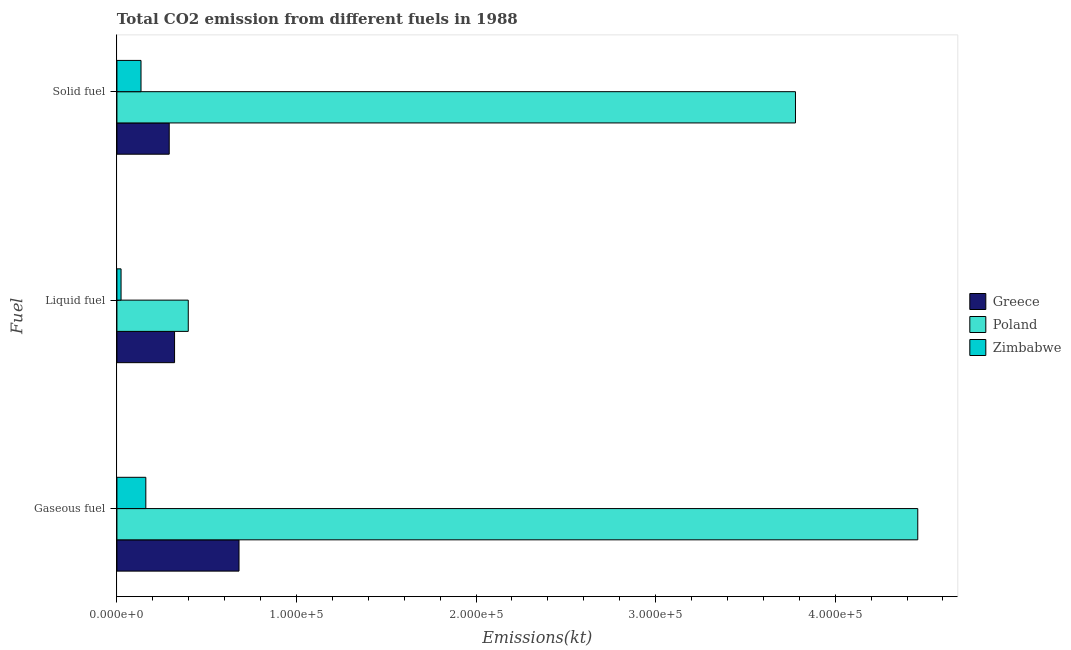How many different coloured bars are there?
Give a very brief answer. 3. How many groups of bars are there?
Provide a succinct answer. 3. Are the number of bars on each tick of the Y-axis equal?
Provide a succinct answer. Yes. How many bars are there on the 1st tick from the top?
Your answer should be very brief. 3. How many bars are there on the 1st tick from the bottom?
Make the answer very short. 3. What is the label of the 2nd group of bars from the top?
Make the answer very short. Liquid fuel. What is the amount of co2 emissions from gaseous fuel in Poland?
Provide a succinct answer. 4.46e+05. Across all countries, what is the maximum amount of co2 emissions from solid fuel?
Provide a succinct answer. 3.78e+05. Across all countries, what is the minimum amount of co2 emissions from solid fuel?
Provide a succinct answer. 1.34e+04. In which country was the amount of co2 emissions from liquid fuel minimum?
Provide a short and direct response. Zimbabwe. What is the total amount of co2 emissions from gaseous fuel in the graph?
Your answer should be very brief. 5.30e+05. What is the difference between the amount of co2 emissions from solid fuel in Poland and that in Greece?
Your answer should be compact. 3.49e+05. What is the difference between the amount of co2 emissions from solid fuel in Poland and the amount of co2 emissions from gaseous fuel in Zimbabwe?
Offer a terse response. 3.62e+05. What is the average amount of co2 emissions from solid fuel per country?
Offer a very short reply. 1.40e+05. What is the difference between the amount of co2 emissions from solid fuel and amount of co2 emissions from liquid fuel in Zimbabwe?
Offer a terse response. 1.11e+04. In how many countries, is the amount of co2 emissions from liquid fuel greater than 100000 kt?
Your response must be concise. 0. What is the ratio of the amount of co2 emissions from gaseous fuel in Greece to that in Poland?
Offer a very short reply. 0.15. Is the amount of co2 emissions from gaseous fuel in Poland less than that in Zimbabwe?
Ensure brevity in your answer.  No. Is the difference between the amount of co2 emissions from liquid fuel in Greece and Zimbabwe greater than the difference between the amount of co2 emissions from gaseous fuel in Greece and Zimbabwe?
Make the answer very short. No. What is the difference between the highest and the second highest amount of co2 emissions from liquid fuel?
Keep it short and to the point. 7631.03. What is the difference between the highest and the lowest amount of co2 emissions from liquid fuel?
Provide a short and direct response. 3.74e+04. What does the 1st bar from the top in Gaseous fuel represents?
Offer a terse response. Zimbabwe. Are all the bars in the graph horizontal?
Your response must be concise. Yes. How many countries are there in the graph?
Give a very brief answer. 3. Are the values on the major ticks of X-axis written in scientific E-notation?
Your answer should be very brief. Yes. Does the graph contain any zero values?
Your answer should be compact. No. Does the graph contain grids?
Make the answer very short. No. How many legend labels are there?
Keep it short and to the point. 3. How are the legend labels stacked?
Ensure brevity in your answer.  Vertical. What is the title of the graph?
Your answer should be compact. Total CO2 emission from different fuels in 1988. What is the label or title of the X-axis?
Ensure brevity in your answer.  Emissions(kt). What is the label or title of the Y-axis?
Offer a very short reply. Fuel. What is the Emissions(kt) in Greece in Gaseous fuel?
Make the answer very short. 6.80e+04. What is the Emissions(kt) in Poland in Gaseous fuel?
Keep it short and to the point. 4.46e+05. What is the Emissions(kt) of Zimbabwe in Gaseous fuel?
Your response must be concise. 1.61e+04. What is the Emissions(kt) of Greece in Liquid fuel?
Provide a short and direct response. 3.21e+04. What is the Emissions(kt) of Poland in Liquid fuel?
Offer a very short reply. 3.97e+04. What is the Emissions(kt) in Zimbabwe in Liquid fuel?
Ensure brevity in your answer.  2302.88. What is the Emissions(kt) in Greece in Solid fuel?
Make the answer very short. 2.91e+04. What is the Emissions(kt) of Poland in Solid fuel?
Give a very brief answer. 3.78e+05. What is the Emissions(kt) of Zimbabwe in Solid fuel?
Offer a terse response. 1.34e+04. Across all Fuel, what is the maximum Emissions(kt) of Greece?
Your answer should be very brief. 6.80e+04. Across all Fuel, what is the maximum Emissions(kt) in Poland?
Keep it short and to the point. 4.46e+05. Across all Fuel, what is the maximum Emissions(kt) in Zimbabwe?
Your answer should be compact. 1.61e+04. Across all Fuel, what is the minimum Emissions(kt) of Greece?
Offer a terse response. 2.91e+04. Across all Fuel, what is the minimum Emissions(kt) in Poland?
Give a very brief answer. 3.97e+04. Across all Fuel, what is the minimum Emissions(kt) in Zimbabwe?
Make the answer very short. 2302.88. What is the total Emissions(kt) of Greece in the graph?
Give a very brief answer. 1.29e+05. What is the total Emissions(kt) in Poland in the graph?
Offer a very short reply. 8.64e+05. What is the total Emissions(kt) of Zimbabwe in the graph?
Your answer should be very brief. 3.18e+04. What is the difference between the Emissions(kt) in Greece in Gaseous fuel and that in Liquid fuel?
Offer a very short reply. 3.59e+04. What is the difference between the Emissions(kt) in Poland in Gaseous fuel and that in Liquid fuel?
Provide a succinct answer. 4.06e+05. What is the difference between the Emissions(kt) of Zimbabwe in Gaseous fuel and that in Liquid fuel?
Provide a succinct answer. 1.38e+04. What is the difference between the Emissions(kt) of Greece in Gaseous fuel and that in Solid fuel?
Your response must be concise. 3.89e+04. What is the difference between the Emissions(kt) in Poland in Gaseous fuel and that in Solid fuel?
Offer a terse response. 6.81e+04. What is the difference between the Emissions(kt) in Zimbabwe in Gaseous fuel and that in Solid fuel?
Offer a terse response. 2687.91. What is the difference between the Emissions(kt) in Greece in Liquid fuel and that in Solid fuel?
Your answer should be compact. 2977.6. What is the difference between the Emissions(kt) in Poland in Liquid fuel and that in Solid fuel?
Make the answer very short. -3.38e+05. What is the difference between the Emissions(kt) in Zimbabwe in Liquid fuel and that in Solid fuel?
Your answer should be very brief. -1.11e+04. What is the difference between the Emissions(kt) in Greece in Gaseous fuel and the Emissions(kt) in Poland in Liquid fuel?
Make the answer very short. 2.83e+04. What is the difference between the Emissions(kt) of Greece in Gaseous fuel and the Emissions(kt) of Zimbabwe in Liquid fuel?
Give a very brief answer. 6.57e+04. What is the difference between the Emissions(kt) in Poland in Gaseous fuel and the Emissions(kt) in Zimbabwe in Liquid fuel?
Offer a terse response. 4.44e+05. What is the difference between the Emissions(kt) in Greece in Gaseous fuel and the Emissions(kt) in Poland in Solid fuel?
Your answer should be compact. -3.10e+05. What is the difference between the Emissions(kt) of Greece in Gaseous fuel and the Emissions(kt) of Zimbabwe in Solid fuel?
Your answer should be compact. 5.46e+04. What is the difference between the Emissions(kt) of Poland in Gaseous fuel and the Emissions(kt) of Zimbabwe in Solid fuel?
Ensure brevity in your answer.  4.33e+05. What is the difference between the Emissions(kt) in Greece in Liquid fuel and the Emissions(kt) in Poland in Solid fuel?
Offer a very short reply. -3.46e+05. What is the difference between the Emissions(kt) in Greece in Liquid fuel and the Emissions(kt) in Zimbabwe in Solid fuel?
Offer a terse response. 1.87e+04. What is the difference between the Emissions(kt) in Poland in Liquid fuel and the Emissions(kt) in Zimbabwe in Solid fuel?
Ensure brevity in your answer.  2.63e+04. What is the average Emissions(kt) of Greece per Fuel?
Make the answer very short. 4.31e+04. What is the average Emissions(kt) in Poland per Fuel?
Offer a very short reply. 2.88e+05. What is the average Emissions(kt) of Zimbabwe per Fuel?
Give a very brief answer. 1.06e+04. What is the difference between the Emissions(kt) in Greece and Emissions(kt) in Poland in Gaseous fuel?
Ensure brevity in your answer.  -3.78e+05. What is the difference between the Emissions(kt) of Greece and Emissions(kt) of Zimbabwe in Gaseous fuel?
Give a very brief answer. 5.19e+04. What is the difference between the Emissions(kt) in Poland and Emissions(kt) in Zimbabwe in Gaseous fuel?
Provide a short and direct response. 4.30e+05. What is the difference between the Emissions(kt) of Greece and Emissions(kt) of Poland in Liquid fuel?
Your answer should be very brief. -7631.03. What is the difference between the Emissions(kt) in Greece and Emissions(kt) in Zimbabwe in Liquid fuel?
Offer a very short reply. 2.98e+04. What is the difference between the Emissions(kt) in Poland and Emissions(kt) in Zimbabwe in Liquid fuel?
Give a very brief answer. 3.74e+04. What is the difference between the Emissions(kt) in Greece and Emissions(kt) in Poland in Solid fuel?
Provide a succinct answer. -3.49e+05. What is the difference between the Emissions(kt) in Greece and Emissions(kt) in Zimbabwe in Solid fuel?
Keep it short and to the point. 1.57e+04. What is the difference between the Emissions(kt) of Poland and Emissions(kt) of Zimbabwe in Solid fuel?
Your answer should be very brief. 3.64e+05. What is the ratio of the Emissions(kt) of Greece in Gaseous fuel to that in Liquid fuel?
Offer a terse response. 2.12. What is the ratio of the Emissions(kt) of Poland in Gaseous fuel to that in Liquid fuel?
Give a very brief answer. 11.23. What is the ratio of the Emissions(kt) of Zimbabwe in Gaseous fuel to that in Liquid fuel?
Ensure brevity in your answer.  6.99. What is the ratio of the Emissions(kt) in Greece in Gaseous fuel to that in Solid fuel?
Give a very brief answer. 2.33. What is the ratio of the Emissions(kt) of Poland in Gaseous fuel to that in Solid fuel?
Give a very brief answer. 1.18. What is the ratio of the Emissions(kt) of Zimbabwe in Gaseous fuel to that in Solid fuel?
Offer a terse response. 1.2. What is the ratio of the Emissions(kt) in Greece in Liquid fuel to that in Solid fuel?
Your answer should be compact. 1.1. What is the ratio of the Emissions(kt) of Poland in Liquid fuel to that in Solid fuel?
Ensure brevity in your answer.  0.11. What is the ratio of the Emissions(kt) in Zimbabwe in Liquid fuel to that in Solid fuel?
Offer a terse response. 0.17. What is the difference between the highest and the second highest Emissions(kt) in Greece?
Your response must be concise. 3.59e+04. What is the difference between the highest and the second highest Emissions(kt) of Poland?
Offer a terse response. 6.81e+04. What is the difference between the highest and the second highest Emissions(kt) in Zimbabwe?
Offer a terse response. 2687.91. What is the difference between the highest and the lowest Emissions(kt) of Greece?
Provide a short and direct response. 3.89e+04. What is the difference between the highest and the lowest Emissions(kt) of Poland?
Provide a succinct answer. 4.06e+05. What is the difference between the highest and the lowest Emissions(kt) of Zimbabwe?
Keep it short and to the point. 1.38e+04. 